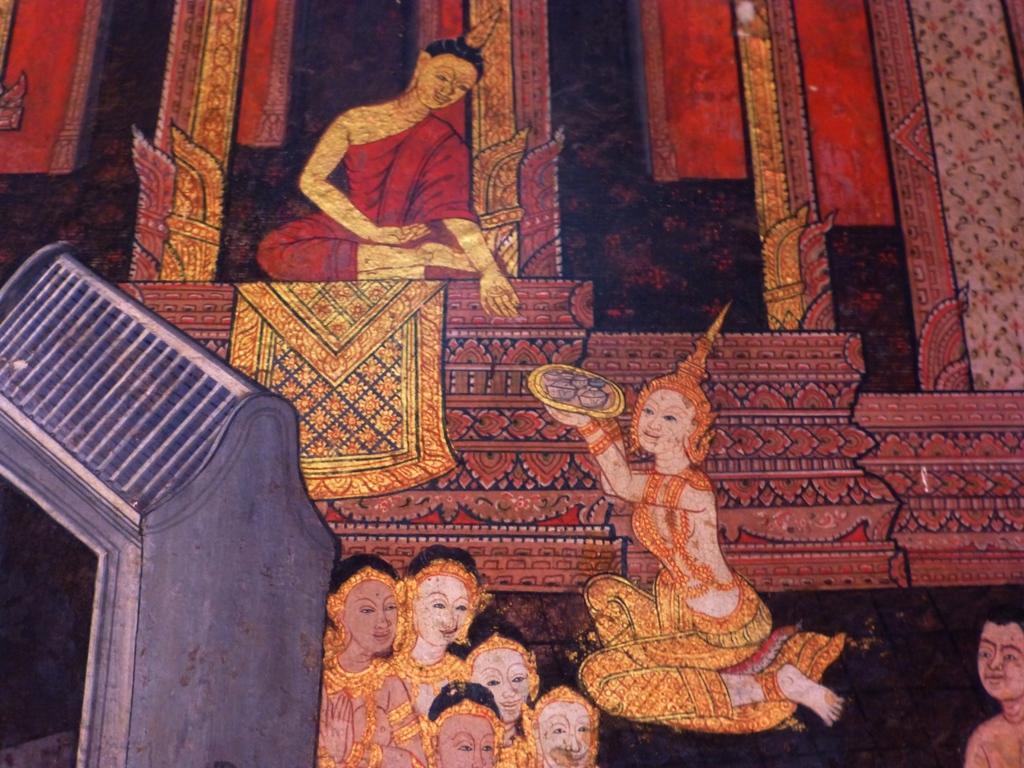How would you summarize this image in a sentence or two? In this image I can see the painting of few persons. In front I can see an object in gray color. 